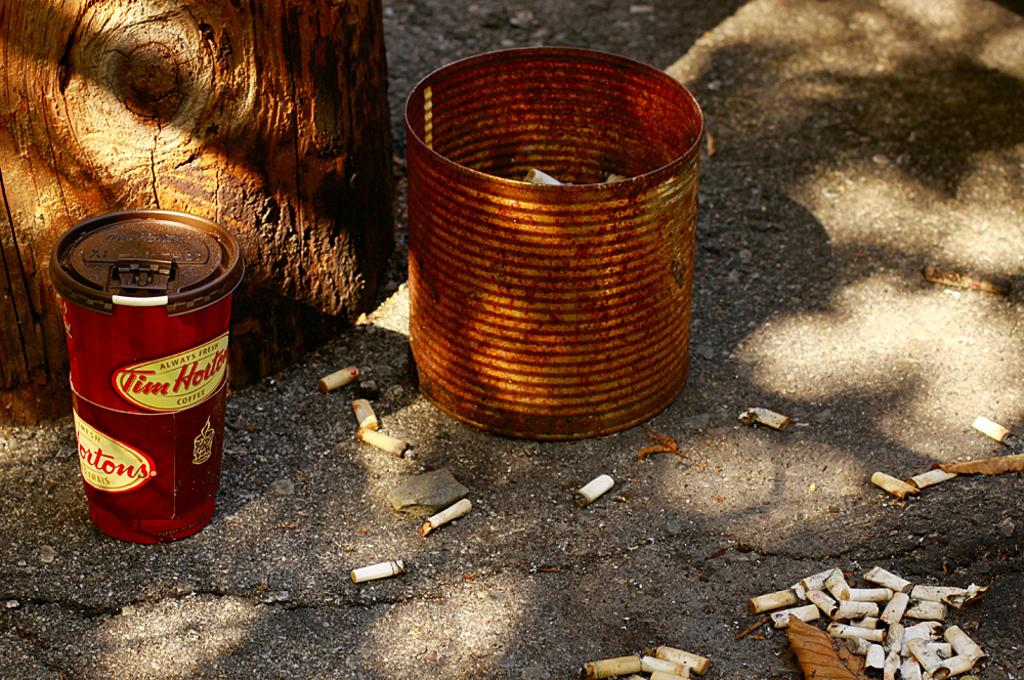<image>
Summarize the visual content of the image. A rusty can next to something with Tim Horton on it. 